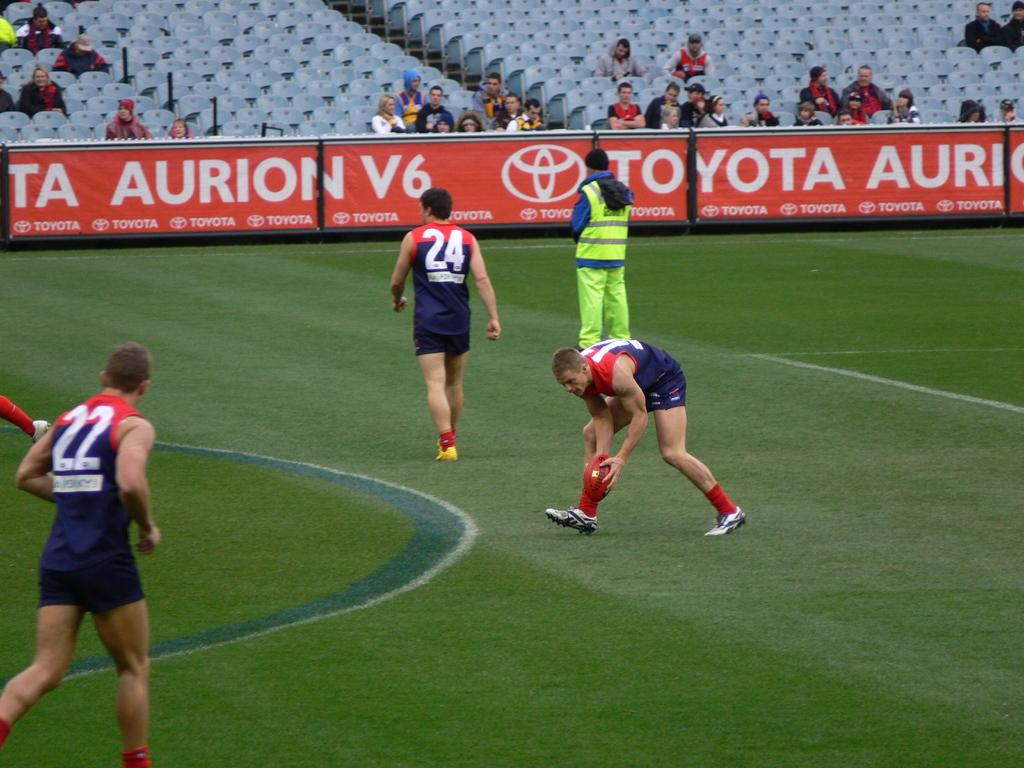Provide a one-sentence caption for the provided image. The side of a rugby stadium is covered with advertisements for Toyota. 